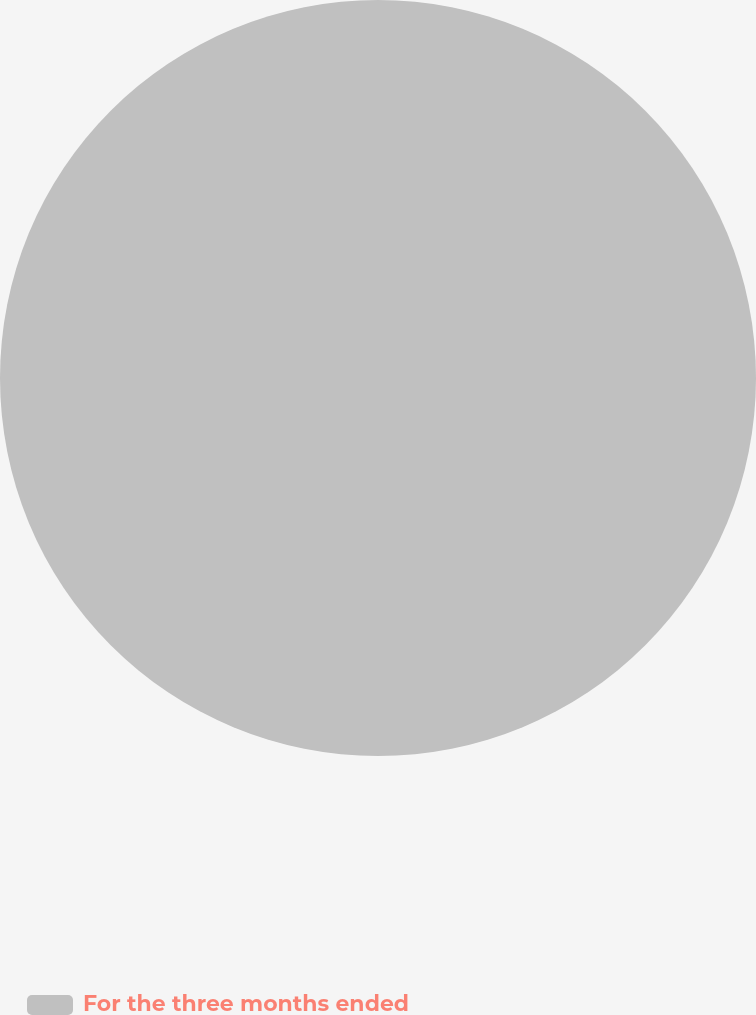Convert chart to OTSL. <chart><loc_0><loc_0><loc_500><loc_500><pie_chart><fcel>For the three months ended<nl><fcel>100.0%<nl></chart> 